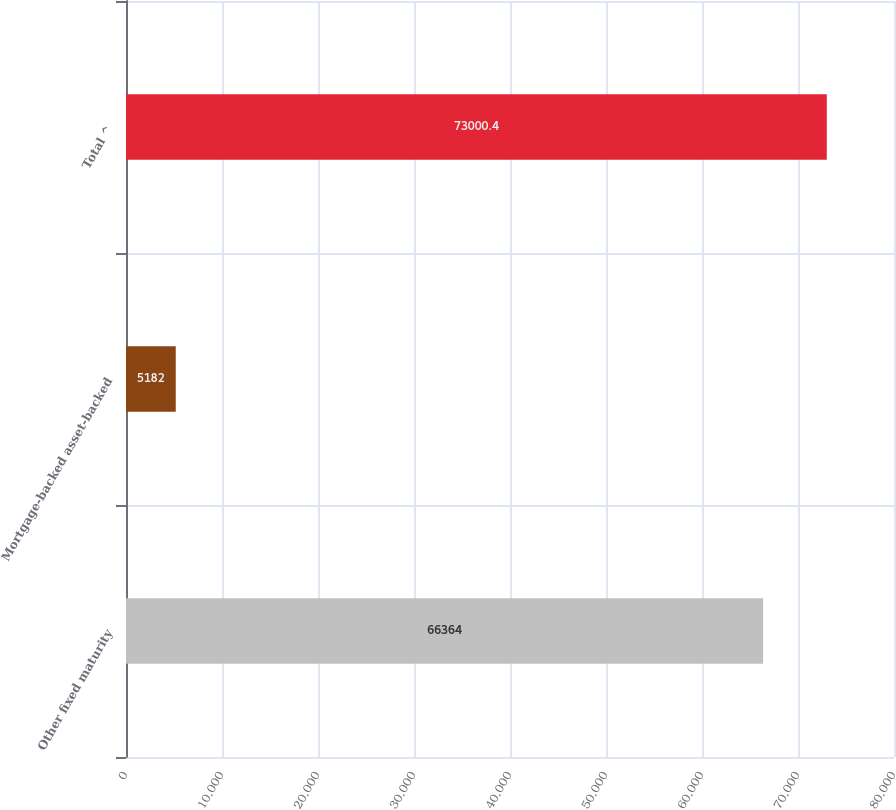<chart> <loc_0><loc_0><loc_500><loc_500><bar_chart><fcel>Other fixed maturity<fcel>Mortgage-backed asset-backed<fcel>Total ^<nl><fcel>66364<fcel>5182<fcel>73000.4<nl></chart> 